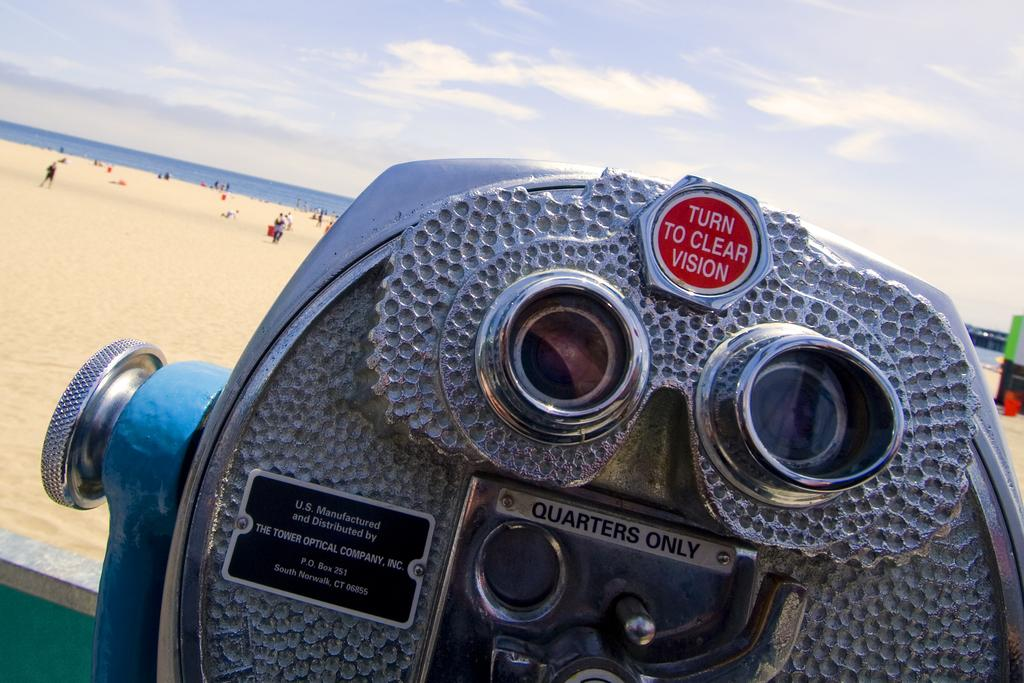What is the main object in the center of the image? There is a binoculars in the center of the image. What can be seen in the background of the image? There are people and a sea visible in the background of the image. What else is visible in the background of the image? The sky is also visible in the background of the image. Can you tell me how many goose are swimming in the sea in the image? There are no goose visible in the image; only people and a sea can be seen in the background. Is there a gun present in the image? There is no gun present in the image. 